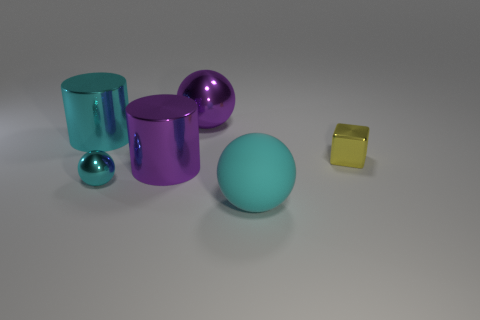Add 2 cyan objects. How many objects exist? 8 Subtract all purple cylinders. How many cylinders are left? 1 Subtract all big balls. How many balls are left? 1 Subtract all cubes. How many objects are left? 5 Subtract 2 balls. How many balls are left? 1 Subtract all blue balls. Subtract all red cylinders. How many balls are left? 3 Subtract all yellow cylinders. How many cyan spheres are left? 2 Subtract all big red matte cylinders. Subtract all metal blocks. How many objects are left? 5 Add 4 large shiny cylinders. How many large shiny cylinders are left? 6 Add 5 big yellow matte blocks. How many big yellow matte blocks exist? 5 